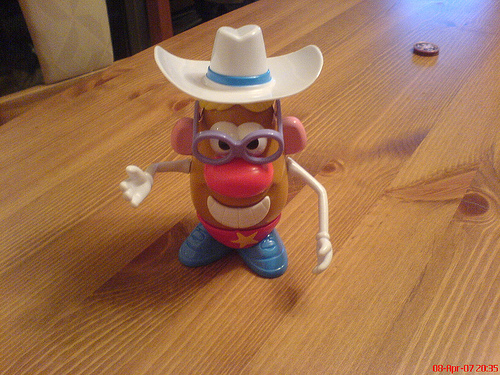<image>
Is there a hat on the potato? Yes. Looking at the image, I can see the hat is positioned on top of the potato, with the potato providing support. 